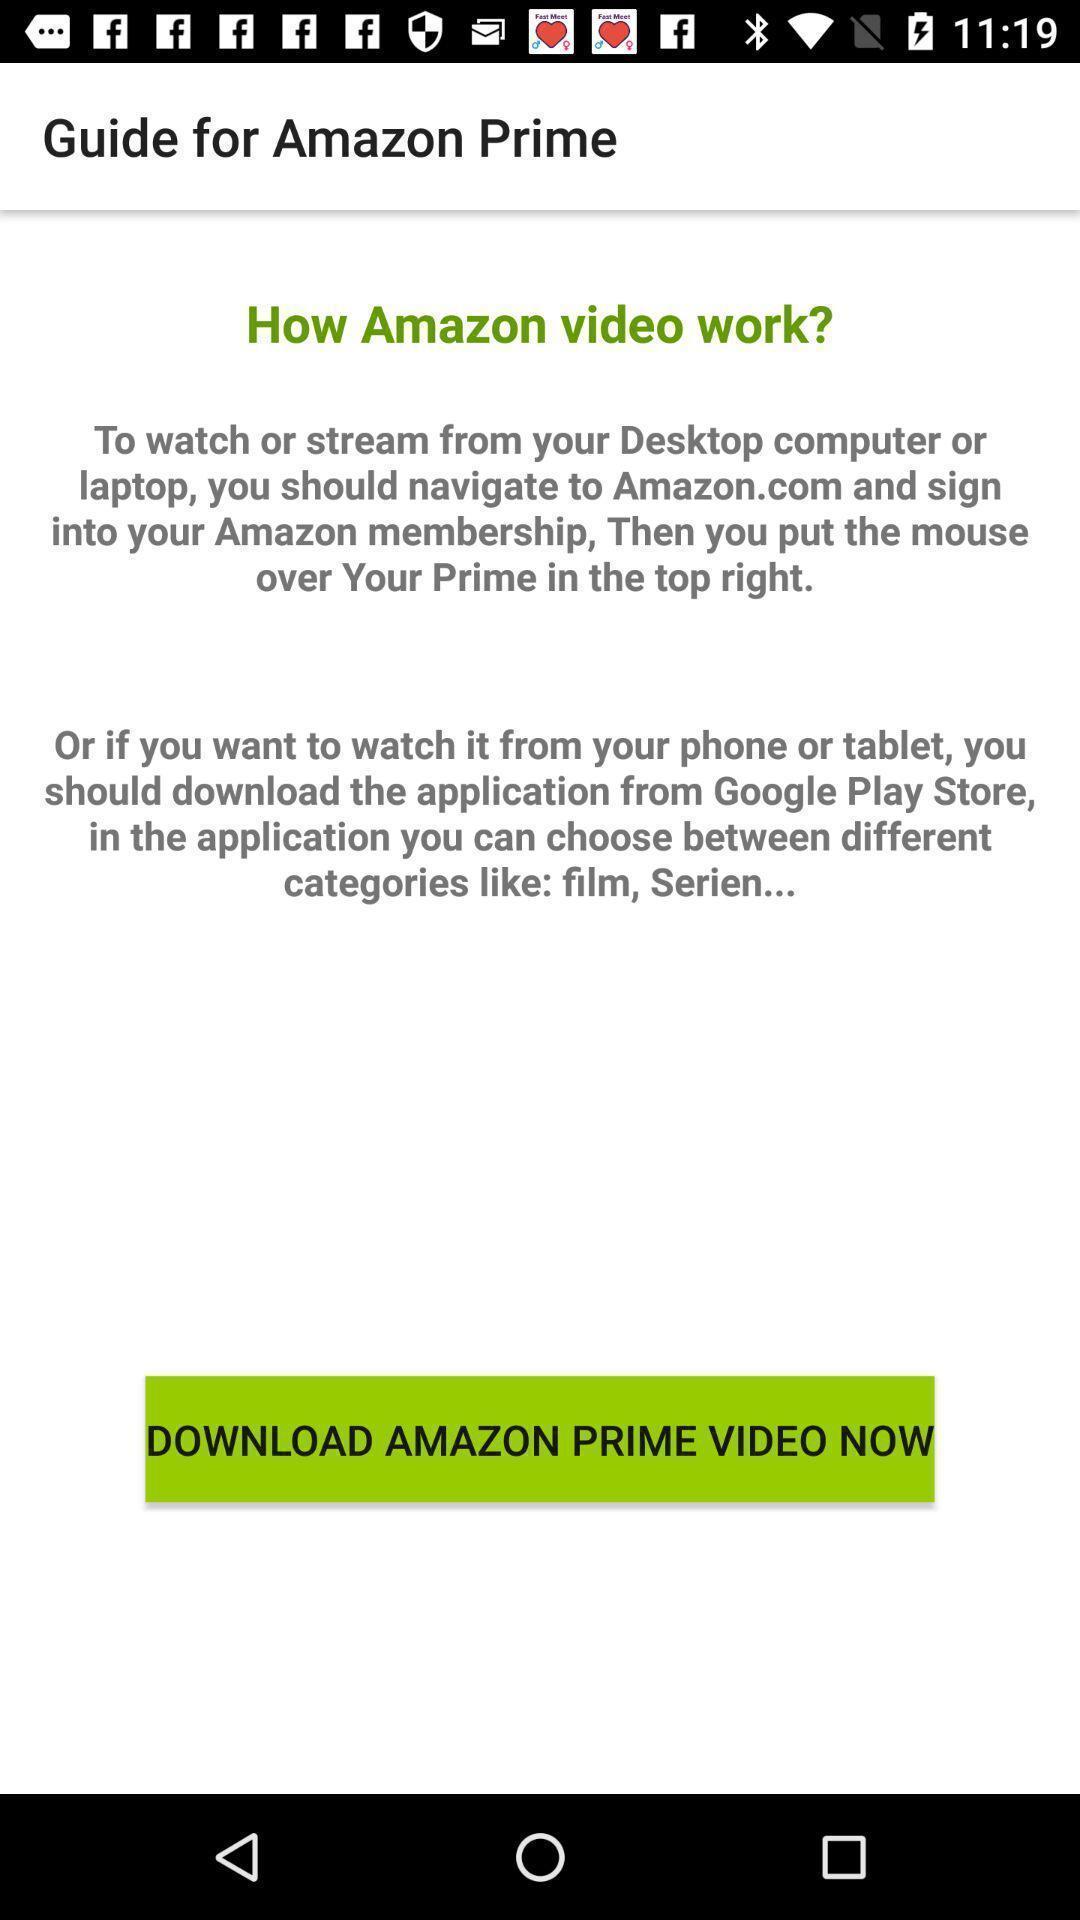Tell me what you see in this picture. Page showing guide in television app. 